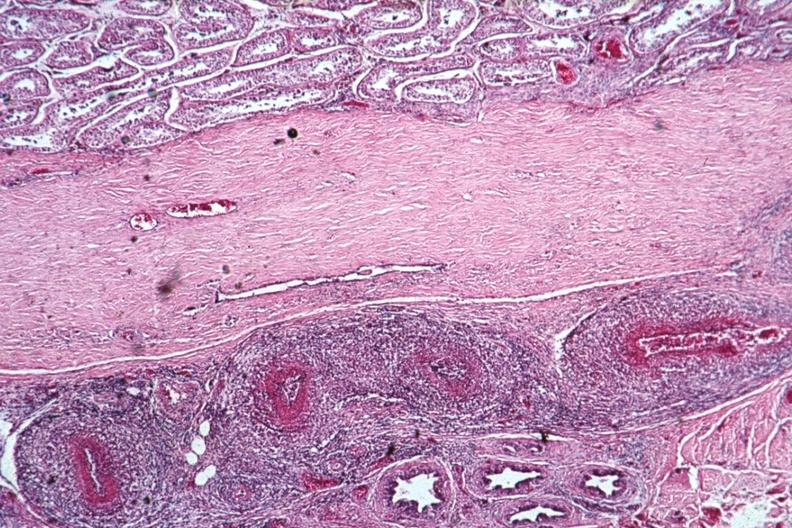what is present?
Answer the question using a single word or phrase. Testicle 